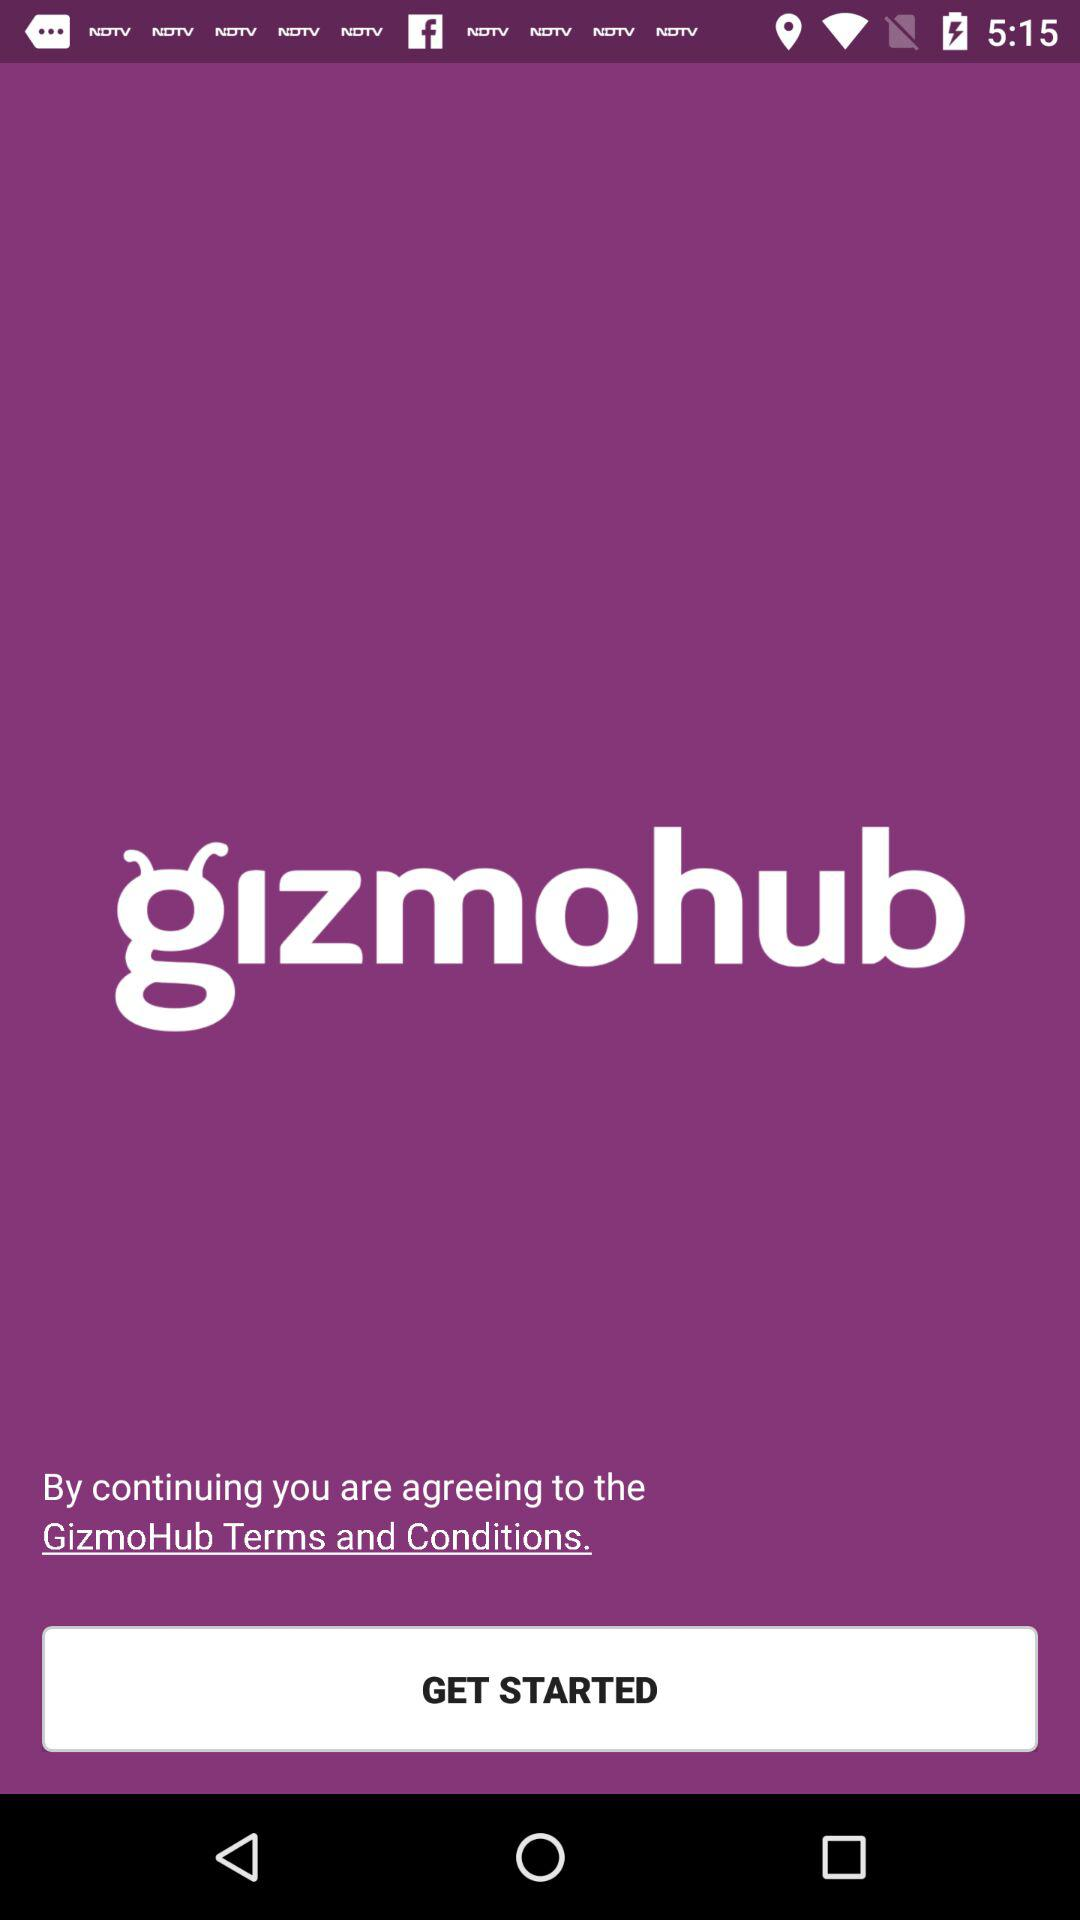What is the application name? The application name is "gizmohub". 